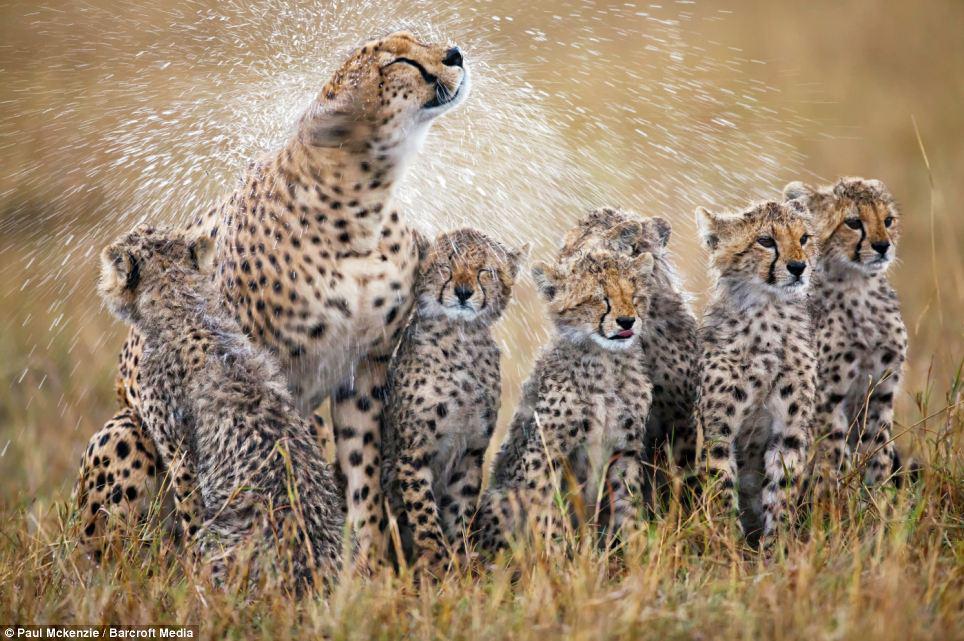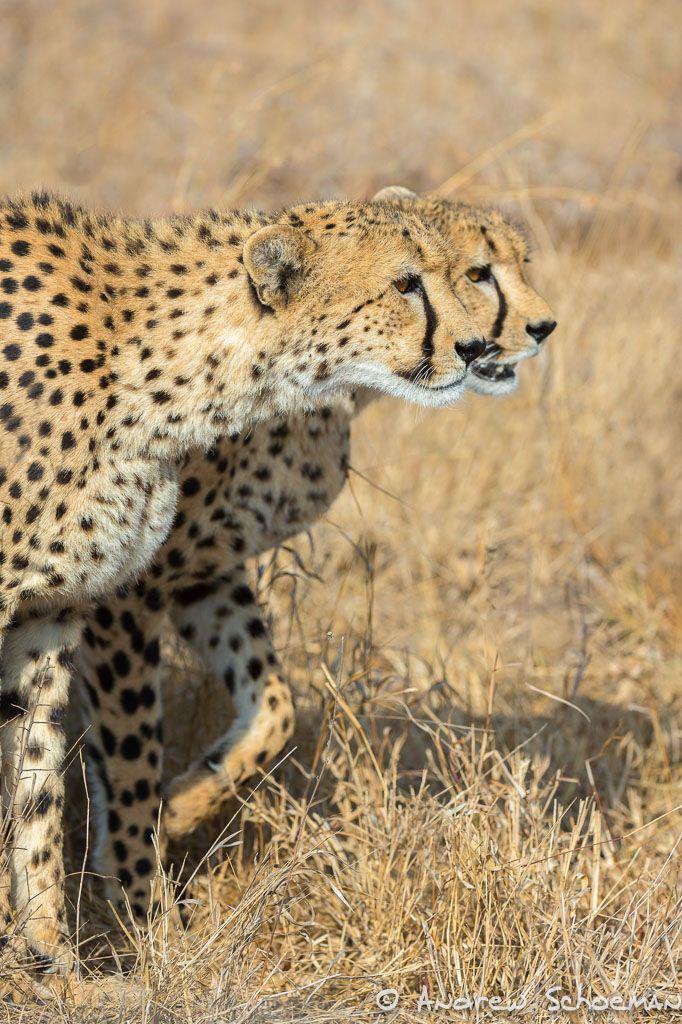The first image is the image on the left, the second image is the image on the right. For the images shown, is this caption "An image shows a spotted wild cat taking down its hooved prey." true? Answer yes or no. No. The first image is the image on the left, the second image is the image on the right. Examine the images to the left and right. Is the description "One or more cheetahs are catching another animal in one of the photos." accurate? Answer yes or no. No. 